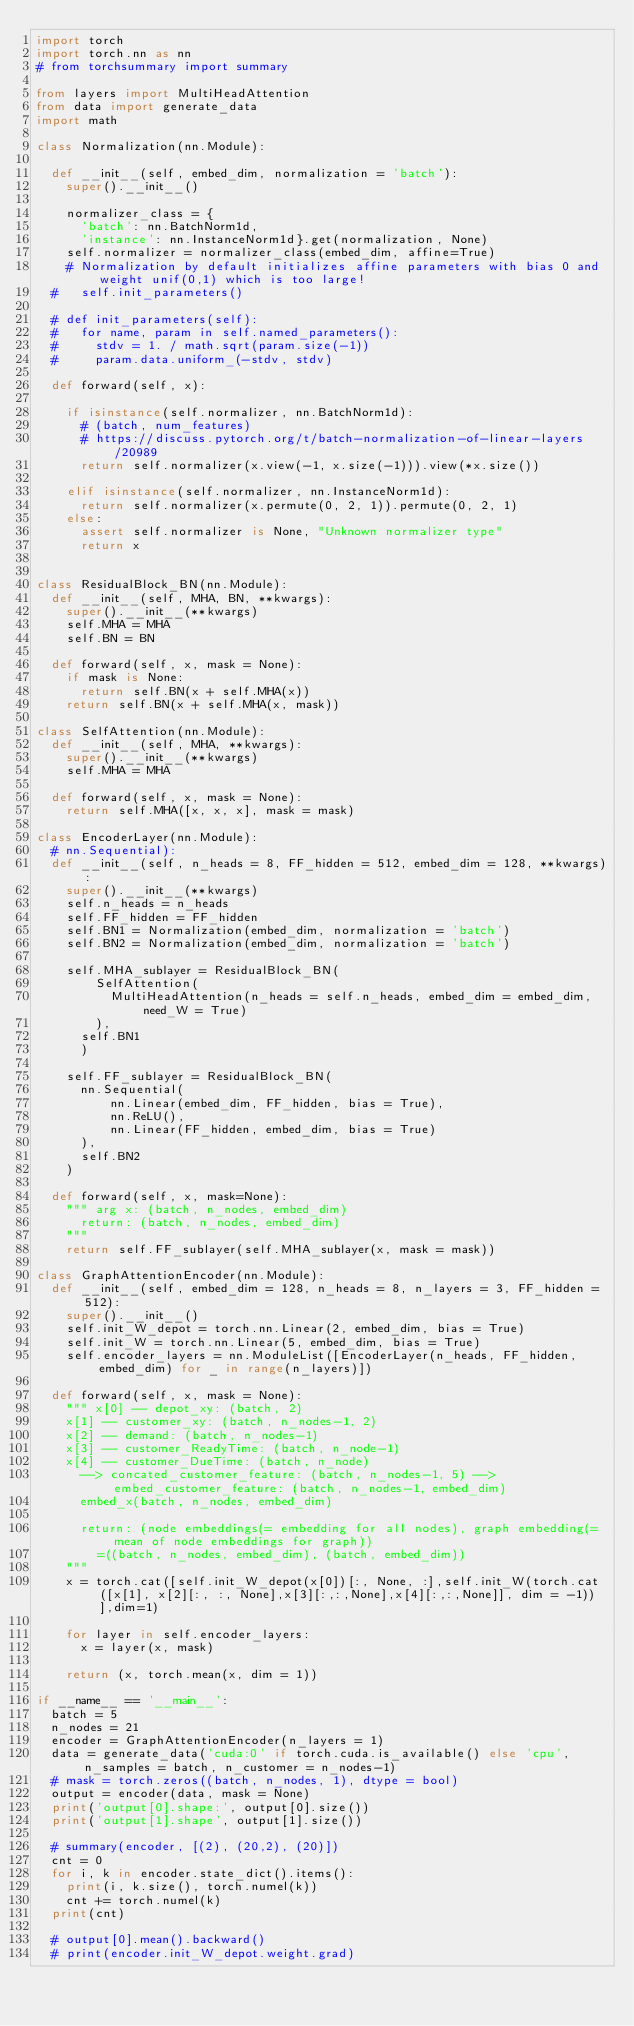Convert code to text. <code><loc_0><loc_0><loc_500><loc_500><_Python_>import torch
import torch.nn as nn
# from torchsummary import summary

from layers import MultiHeadAttention
from data import generate_data
import math

class Normalization(nn.Module):

	def __init__(self, embed_dim, normalization = 'batch'):
		super().__init__()

		normalizer_class = {
			'batch': nn.BatchNorm1d,
			'instance': nn.InstanceNorm1d}.get(normalization, None)
		self.normalizer = normalizer_class(embed_dim, affine=True)
		# Normalization by default initializes affine parameters with bias 0 and weight unif(0,1) which is too large!
	# 	self.init_parameters()

	# def init_parameters(self):
	# 	for name, param in self.named_parameters():
	# 		stdv = 1. / math.sqrt(param.size(-1))
	# 		param.data.uniform_(-stdv, stdv)

	def forward(self, x):

		if isinstance(self.normalizer, nn.BatchNorm1d):
			# (batch, num_features)
			# https://discuss.pytorch.org/t/batch-normalization-of-linear-layers/20989
			return self.normalizer(x.view(-1, x.size(-1))).view(*x.size())
		
		elif isinstance(self.normalizer, nn.InstanceNorm1d):
			return self.normalizer(x.permute(0, 2, 1)).permute(0, 2, 1)
		else:
			assert self.normalizer is None, "Unknown normalizer type"
			return x


class ResidualBlock_BN(nn.Module):
	def __init__(self, MHA, BN, **kwargs):
		super().__init__(**kwargs)
		self.MHA = MHA
		self.BN = BN

	def forward(self, x, mask = None):
		if mask is None:
			return self.BN(x + self.MHA(x))
		return self.BN(x + self.MHA(x, mask))

class SelfAttention(nn.Module):
	def __init__(self, MHA, **kwargs):
		super().__init__(**kwargs)
		self.MHA = MHA

	def forward(self, x, mask = None):
		return self.MHA([x, x, x], mask = mask)

class EncoderLayer(nn.Module):
	# nn.Sequential):
	def __init__(self, n_heads = 8, FF_hidden = 512, embed_dim = 128, **kwargs):
		super().__init__(**kwargs)
		self.n_heads = n_heads
		self.FF_hidden = FF_hidden
		self.BN1 = Normalization(embed_dim, normalization = 'batch')
		self.BN2 = Normalization(embed_dim, normalization = 'batch')

		self.MHA_sublayer = ResidualBlock_BN(
				SelfAttention(
					MultiHeadAttention(n_heads = self.n_heads, embed_dim = embed_dim, need_W = True)
				),
			self.BN1
			)

		self.FF_sublayer = ResidualBlock_BN(
			nn.Sequential(
					nn.Linear(embed_dim, FF_hidden, bias = True),
					nn.ReLU(),
					nn.Linear(FF_hidden, embed_dim, bias = True)
			),
			self.BN2
		)
		
	def forward(self, x, mask=None):
		"""	arg x: (batch, n_nodes, embed_dim)
			return: (batch, n_nodes, embed_dim)
		"""
		return self.FF_sublayer(self.MHA_sublayer(x, mask = mask))
		
class GraphAttentionEncoder(nn.Module):
	def __init__(self, embed_dim = 128, n_heads = 8, n_layers = 3, FF_hidden = 512):
		super().__init__()
		self.init_W_depot = torch.nn.Linear(2, embed_dim, bias = True)
		self.init_W = torch.nn.Linear(5, embed_dim, bias = True)
		self.encoder_layers = nn.ModuleList([EncoderLayer(n_heads, FF_hidden, embed_dim) for _ in range(n_layers)])
	
	def forward(self, x, mask = None):
		""" x[0] -- depot_xy: (batch, 2)
		x[1] -- customer_xy: (batch, n_nodes-1, 2)
		x[2] -- demand: (batch, n_nodes-1)
		x[3] -- customer_ReadyTime: (batch, n_node-1)
		x[4] -- customer_DueTime: (batch, n_node)
			--> concated_customer_feature: (batch, n_nodes-1, 5) --> embed_customer_feature: (batch, n_nodes-1, embed_dim)
			embed_x(batch, n_nodes, embed_dim)

			return: (node embeddings(= embedding for all nodes), graph embedding(= mean of node embeddings for graph))
				=((batch, n_nodes, embed_dim), (batch, embed_dim))
		"""
		x = torch.cat([self.init_W_depot(x[0])[:, None, :],self.init_W(torch.cat([x[1], x[2][:, :, None],x[3][:,:,None],x[4][:,:,None]], dim = -1))],dim=1)
	
		for layer in self.encoder_layers:
			x = layer(x, mask)

		return (x, torch.mean(x, dim = 1))

if __name__ == '__main__':
	batch = 5
	n_nodes = 21
	encoder = GraphAttentionEncoder(n_layers = 1)
	data = generate_data('cuda:0' if torch.cuda.is_available() else 'cpu',n_samples = batch, n_customer = n_nodes-1)
	# mask = torch.zeros((batch, n_nodes, 1), dtype = bool)
	output = encoder(data, mask = None)
	print('output[0].shape:', output[0].size())
	print('output[1].shape', output[1].size())
	
	# summary(encoder, [(2), (20,2), (20)])
	cnt = 0
	for i, k in encoder.state_dict().items():
		print(i, k.size(), torch.numel(k))
		cnt += torch.numel(k)
	print(cnt)

	# output[0].mean().backward()
	# print(encoder.init_W_depot.weight.grad)

</code> 